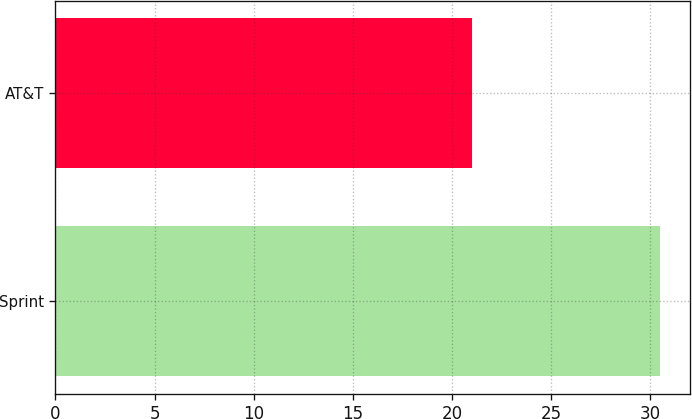Convert chart to OTSL. <chart><loc_0><loc_0><loc_500><loc_500><bar_chart><fcel>Sprint<fcel>AT&T<nl><fcel>30.5<fcel>21<nl></chart> 